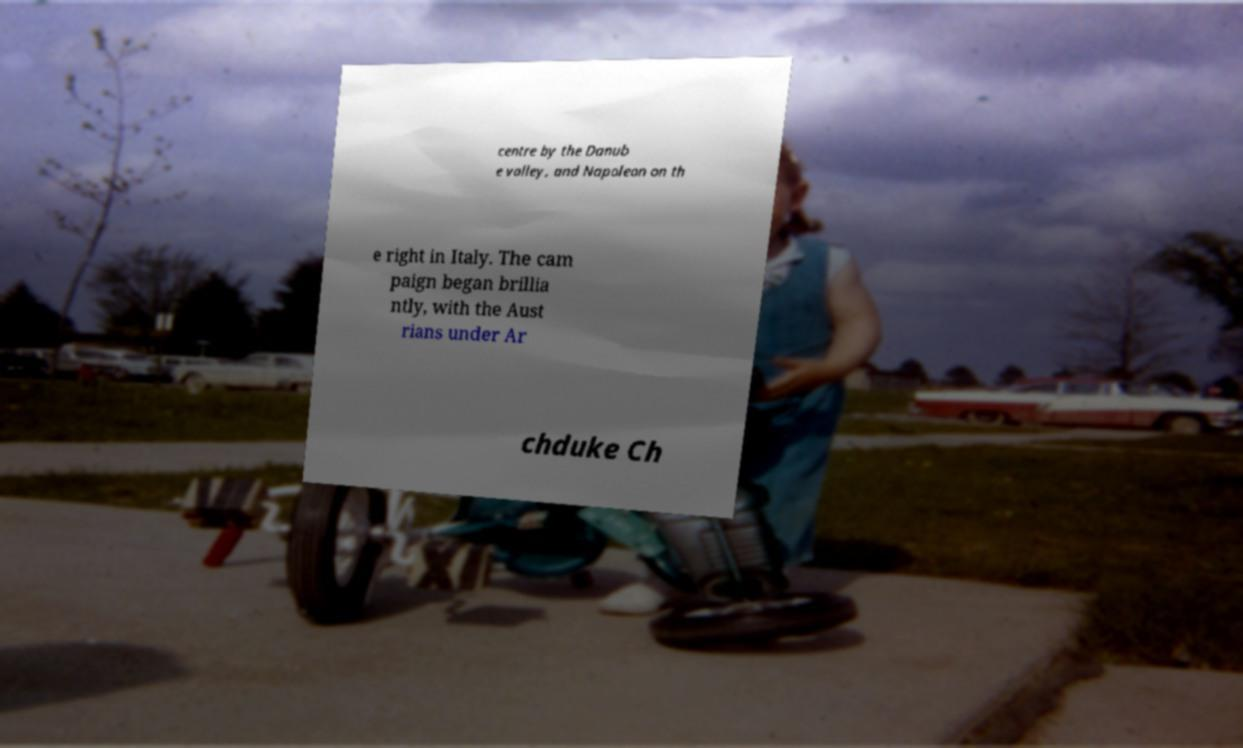Can you read and provide the text displayed in the image?This photo seems to have some interesting text. Can you extract and type it out for me? centre by the Danub e valley, and Napoleon on th e right in Italy. The cam paign began brillia ntly, with the Aust rians under Ar chduke Ch 